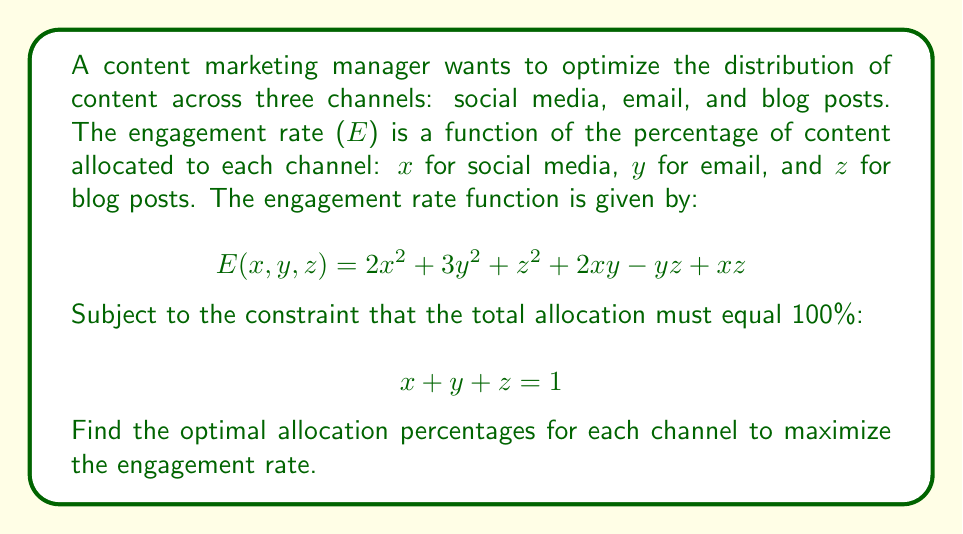Give your solution to this math problem. To solve this optimization problem with a constraint, we'll use the method of Lagrange multipliers.

1. Form the Lagrangian function:
   $$L(x, y, z, λ) = E(x, y, z) - λ(x + y + z - 1)$$
   $$L(x, y, z, λ) = 2x^2 + 3y^2 + z^2 + 2xy - yz + xz - λ(x + y + z - 1)$$

2. Take partial derivatives and set them equal to zero:
   $$\frac{\partial L}{\partial x} = 4x + 2y + z - λ = 0$$
   $$\frac{\partial L}{\partial y} = 6y + 2x - z - λ = 0$$
   $$\frac{\partial L}{\partial z} = 2z - y + x - λ = 0$$
   $$\frac{\partial L}{\partial λ} = x + y + z - 1 = 0$$

3. Solve the system of equations:
   From (1): $λ = 4x + 2y + z$
   From (2): $λ = 6y + 2x - z$
   From (3): $λ = 2z - y + x$

   Equating these:
   $$4x + 2y + z = 6y + 2x - z = 2z - y + x$$

   From the first two parts:
   $$2x + 3y + 2z = 0 \quad (4)$$

   From the last two parts:
   $$5y - 3z + x = 0 \quad (5)$$

   Using (4), (5), and the constraint equation:
   $$2x + 3y + 2z = 0$$
   $$x + 5y - 3z = 0$$
   $$x + y + z = 1$$

4. Solve this system of linear equations:
   $$x = \frac{11}{31}, \quad y = \frac{9}{31}, \quad z = \frac{11}{31}$$

5. Verify that this is a maximum by checking the second derivatives (Hessian matrix is negative definite at this point).
Answer: The optimal allocation percentages to maximize engagement rate are:

Social media (x): $\frac{11}{31} \approx 35.48\%$
Email (y): $\frac{9}{31} \approx 29.03\%$
Blog posts (z): $\frac{11}{31} \approx 35.48\%$ 